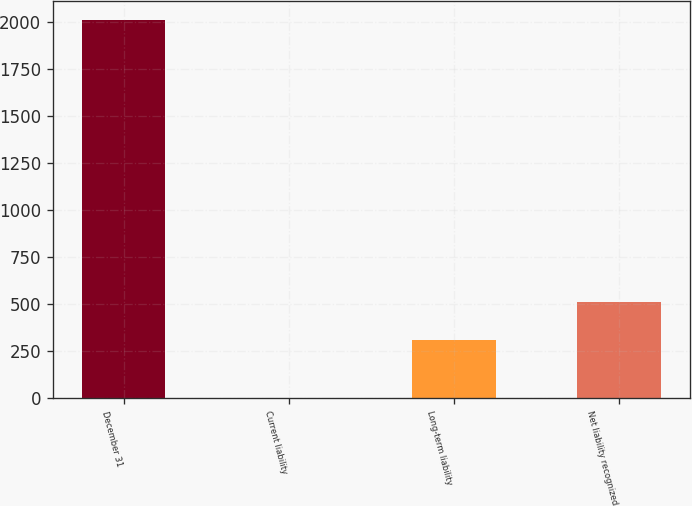Convert chart. <chart><loc_0><loc_0><loc_500><loc_500><bar_chart><fcel>December 31<fcel>Current liability<fcel>Long-term liability<fcel>Net liability recognized<nl><fcel>2009<fcel>1<fcel>309<fcel>509.8<nl></chart> 